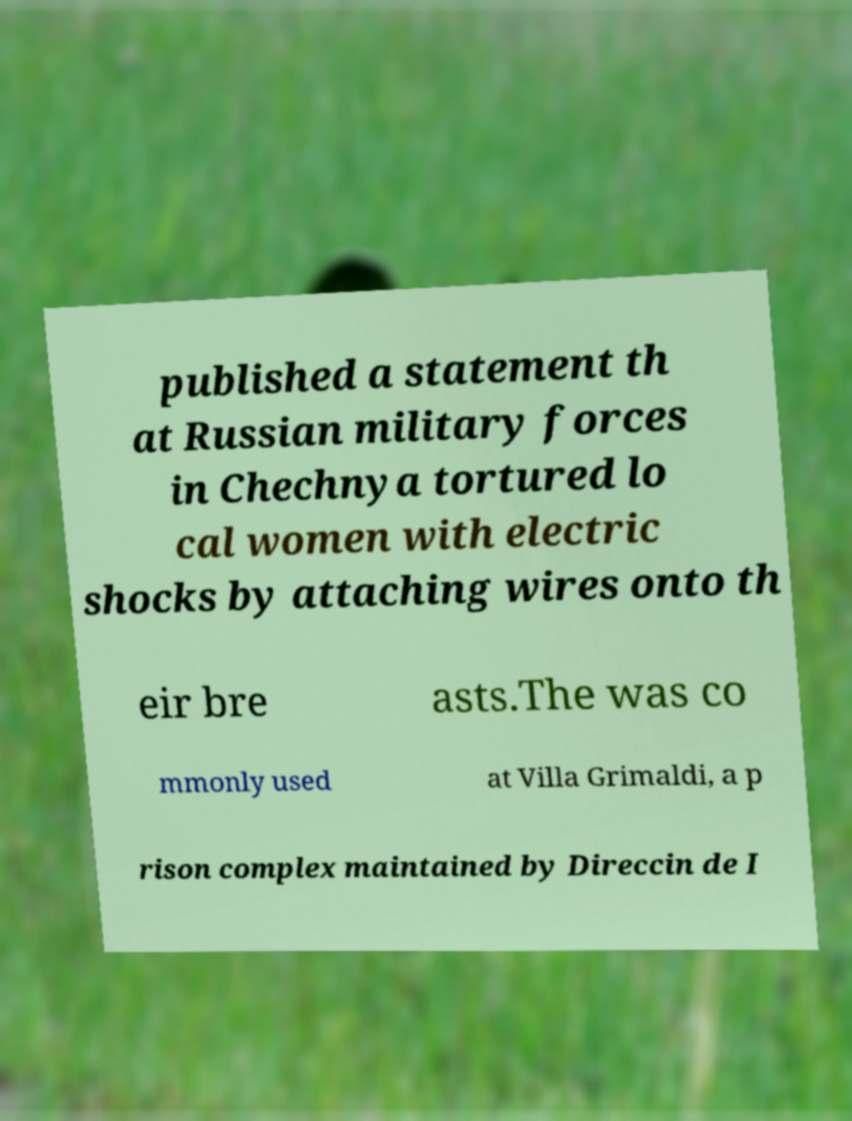Please read and relay the text visible in this image. What does it say? published a statement th at Russian military forces in Chechnya tortured lo cal women with electric shocks by attaching wires onto th eir bre asts.The was co mmonly used at Villa Grimaldi, a p rison complex maintained by Direccin de I 